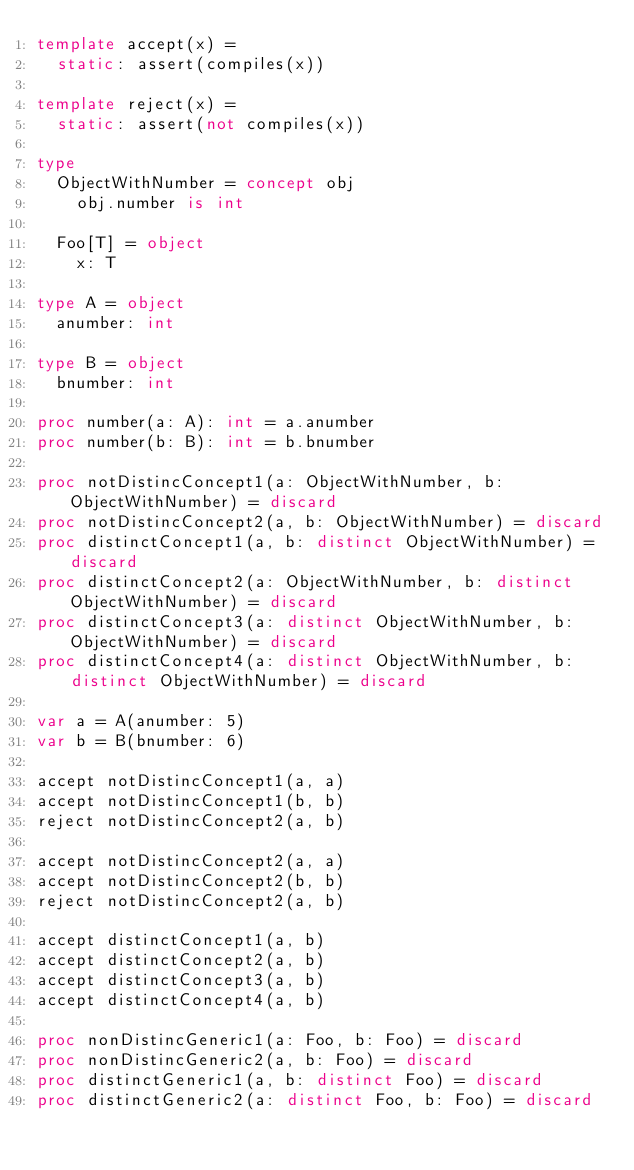Convert code to text. <code><loc_0><loc_0><loc_500><loc_500><_Nim_>template accept(x) =
  static: assert(compiles(x))

template reject(x) =
  static: assert(not compiles(x))

type
  ObjectWithNumber = concept obj
    obj.number is int

  Foo[T] = object
    x: T

type A = object
  anumber: int

type B = object
  bnumber: int

proc number(a: A): int = a.anumber
proc number(b: B): int = b.bnumber

proc notDistincConcept1(a: ObjectWithNumber, b: ObjectWithNumber) = discard
proc notDistincConcept2(a, b: ObjectWithNumber) = discard
proc distinctConcept1(a, b: distinct ObjectWithNumber) = discard
proc distinctConcept2(a: ObjectWithNumber, b: distinct ObjectWithNumber) = discard
proc distinctConcept3(a: distinct ObjectWithNumber, b: ObjectWithNumber) = discard
proc distinctConcept4(a: distinct ObjectWithNumber, b: distinct ObjectWithNumber) = discard

var a = A(anumber: 5)
var b = B(bnumber: 6)

accept notDistincConcept1(a, a)
accept notDistincConcept1(b, b)
reject notDistincConcept2(a, b)

accept notDistincConcept2(a, a)
accept notDistincConcept2(b, b)
reject notDistincConcept2(a, b)

accept distinctConcept1(a, b)
accept distinctConcept2(a, b)
accept distinctConcept3(a, b)
accept distinctConcept4(a, b)

proc nonDistincGeneric1(a: Foo, b: Foo) = discard
proc nonDistincGeneric2(a, b: Foo) = discard
proc distinctGeneric1(a, b: distinct Foo) = discard
proc distinctGeneric2(a: distinct Foo, b: Foo) = discard</code> 